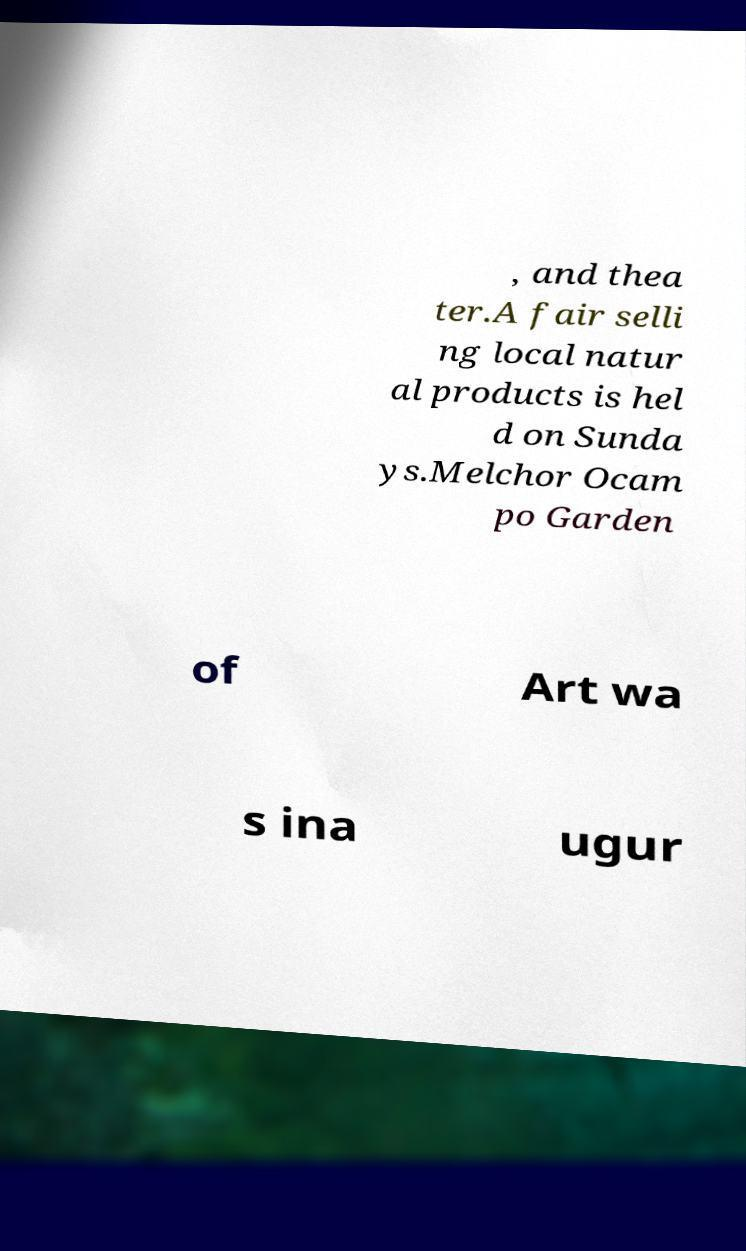Can you accurately transcribe the text from the provided image for me? , and thea ter.A fair selli ng local natur al products is hel d on Sunda ys.Melchor Ocam po Garden of Art wa s ina ugur 